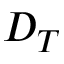<formula> <loc_0><loc_0><loc_500><loc_500>D _ { T }</formula> 